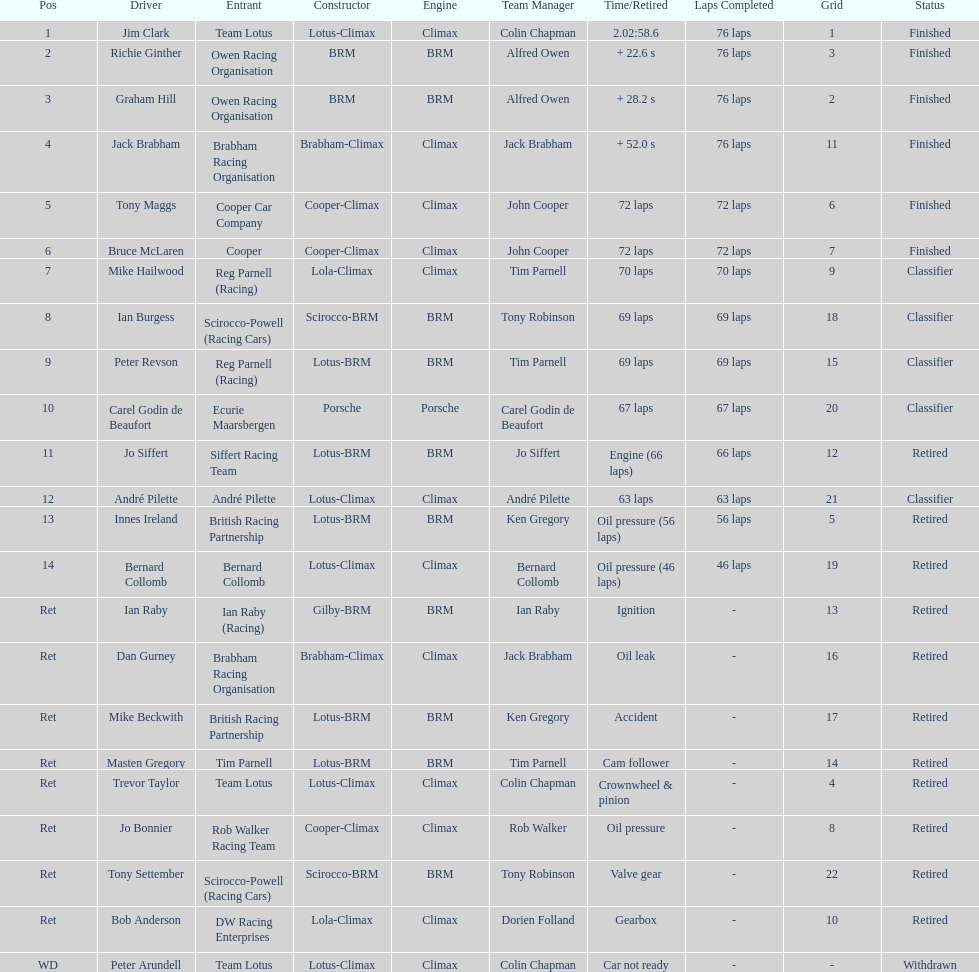What is the number of americans in the top 5? 1. 